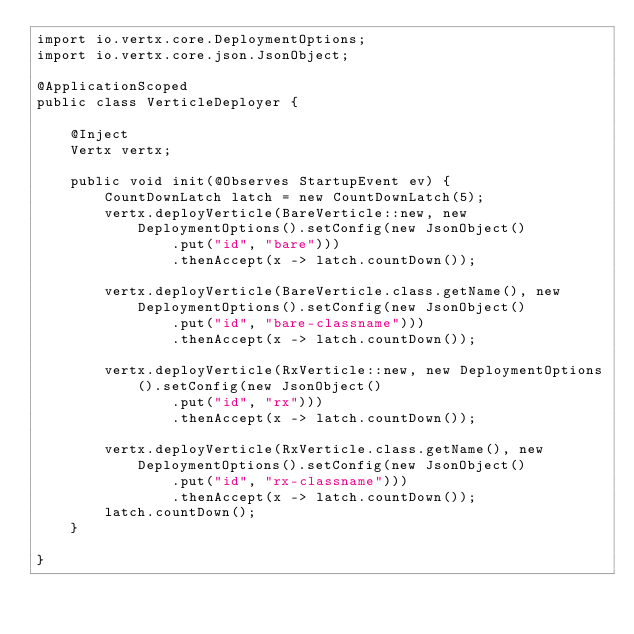<code> <loc_0><loc_0><loc_500><loc_500><_Java_>import io.vertx.core.DeploymentOptions;
import io.vertx.core.json.JsonObject;

@ApplicationScoped
public class VerticleDeployer {

    @Inject
    Vertx vertx;

    public void init(@Observes StartupEvent ev) {
        CountDownLatch latch = new CountDownLatch(5);
        vertx.deployVerticle(BareVerticle::new, new DeploymentOptions().setConfig(new JsonObject()
                .put("id", "bare")))
                .thenAccept(x -> latch.countDown());

        vertx.deployVerticle(BareVerticle.class.getName(), new DeploymentOptions().setConfig(new JsonObject()
                .put("id", "bare-classname")))
                .thenAccept(x -> latch.countDown());

        vertx.deployVerticle(RxVerticle::new, new DeploymentOptions().setConfig(new JsonObject()
                .put("id", "rx")))
                .thenAccept(x -> latch.countDown());

        vertx.deployVerticle(RxVerticle.class.getName(), new DeploymentOptions().setConfig(new JsonObject()
                .put("id", "rx-classname")))
                .thenAccept(x -> latch.countDown());
        latch.countDown();
    }

}
</code> 